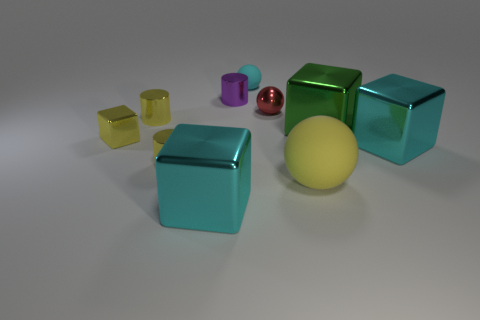Subtract all tiny blocks. How many blocks are left? 3 Subtract all green blocks. How many blocks are left? 3 Subtract 4 cubes. How many cubes are left? 0 Subtract all spheres. How many objects are left? 7 Subtract all brown balls. How many red cylinders are left? 0 Subtract all big green metal things. Subtract all big metal blocks. How many objects are left? 6 Add 3 small purple metallic things. How many small purple metallic things are left? 4 Add 9 tiny purple objects. How many tiny purple objects exist? 10 Subtract 0 cyan cylinders. How many objects are left? 10 Subtract all red cylinders. Subtract all brown spheres. How many cylinders are left? 3 